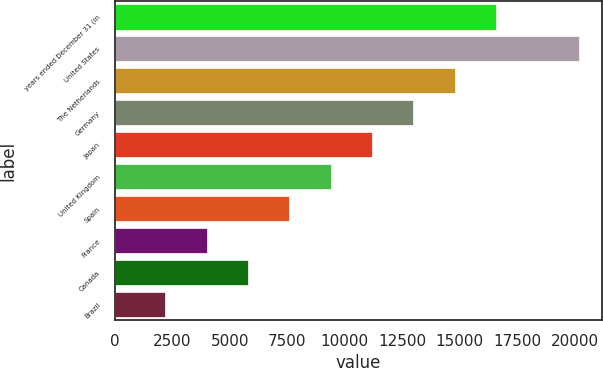<chart> <loc_0><loc_0><loc_500><loc_500><bar_chart><fcel>years ended December 31 (in<fcel>United States<fcel>The Netherlands<fcel>Germany<fcel>Japan<fcel>United Kingdom<fcel>Spain<fcel>France<fcel>Canada<fcel>Brazil<nl><fcel>16582.8<fcel>20177.2<fcel>14785.6<fcel>12988.4<fcel>11191.2<fcel>9394<fcel>7596.8<fcel>4002.4<fcel>5799.6<fcel>2205.2<nl></chart> 